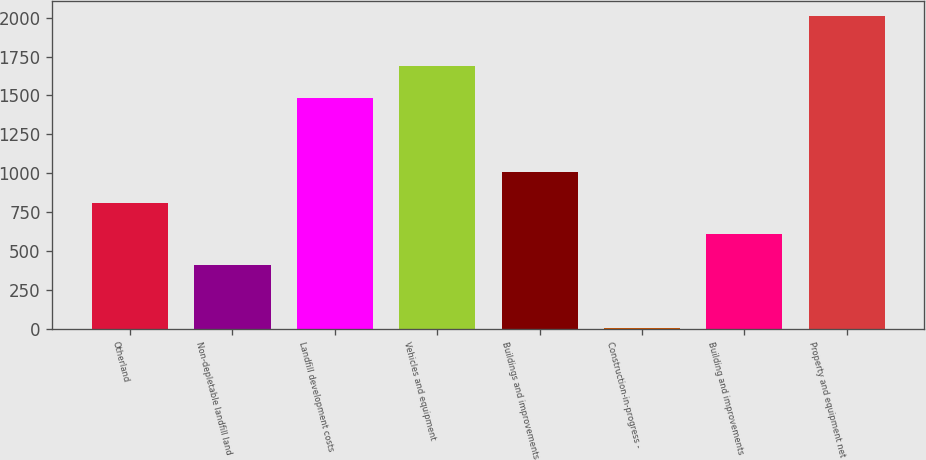<chart> <loc_0><loc_0><loc_500><loc_500><bar_chart><fcel>Otherland<fcel>Non-depletable landfill land<fcel>Landfill development costs<fcel>Vehicles and equipment<fcel>Buildings and improvements<fcel>Construction-in-progress -<fcel>Building and improvements<fcel>Property and equipment net<nl><fcel>807.96<fcel>407.68<fcel>1486.5<fcel>1686.64<fcel>1008.1<fcel>7.4<fcel>607.82<fcel>2008.8<nl></chart> 